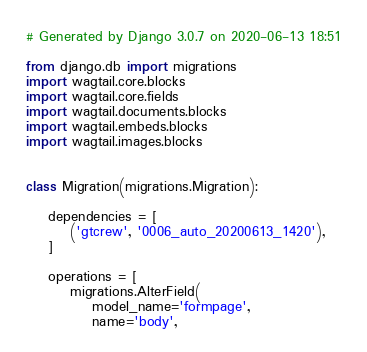Convert code to text. <code><loc_0><loc_0><loc_500><loc_500><_Python_># Generated by Django 3.0.7 on 2020-06-13 18:51

from django.db import migrations
import wagtail.core.blocks
import wagtail.core.fields
import wagtail.documents.blocks
import wagtail.embeds.blocks
import wagtail.images.blocks


class Migration(migrations.Migration):

    dependencies = [
        ('gtcrew', '0006_auto_20200613_1420'),
    ]

    operations = [
        migrations.AlterField(
            model_name='formpage',
            name='body',</code> 